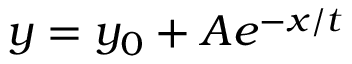Convert formula to latex. <formula><loc_0><loc_0><loc_500><loc_500>y = y _ { 0 } + A e ^ { - x / t }</formula> 